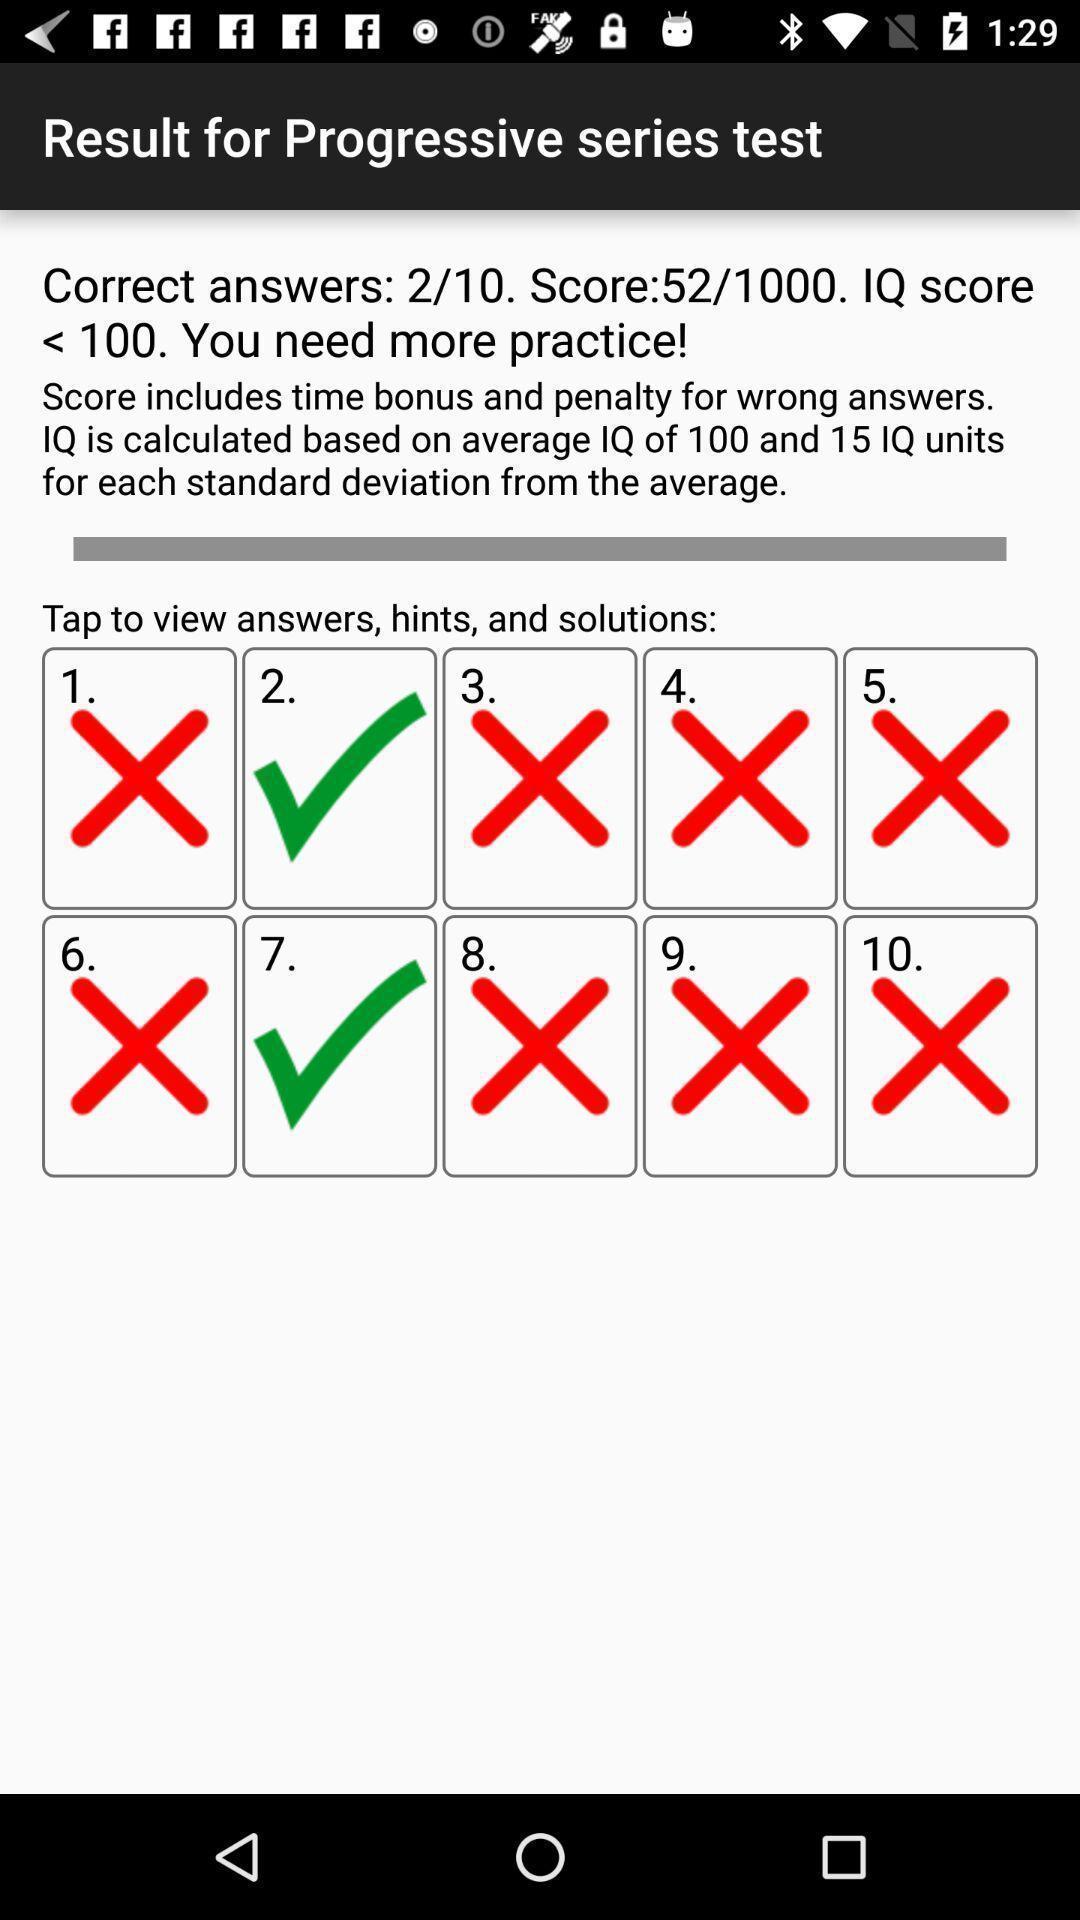Tell me what you see in this picture. Results page of a iq test app. 